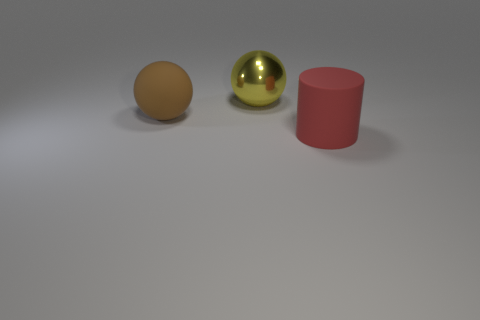Subtract 1 cylinders. How many cylinders are left? 0 Add 2 large metal things. How many objects exist? 5 Subtract all cylinders. How many objects are left? 2 Subtract all brown balls. How many balls are left? 1 Subtract all tiny blue matte spheres. Subtract all red objects. How many objects are left? 2 Add 1 large cylinders. How many large cylinders are left? 2 Add 3 big red metallic cylinders. How many big red metallic cylinders exist? 3 Subtract 1 red cylinders. How many objects are left? 2 Subtract all red balls. Subtract all brown blocks. How many balls are left? 2 Subtract all red blocks. How many brown spheres are left? 1 